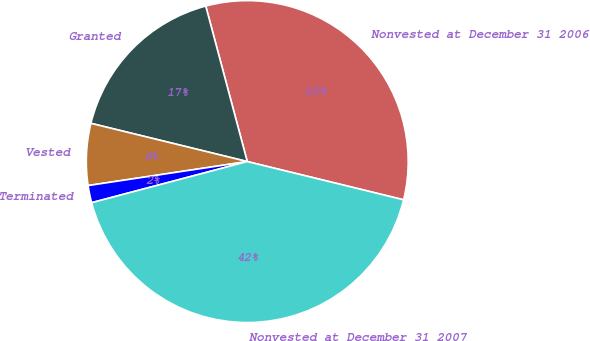Convert chart to OTSL. <chart><loc_0><loc_0><loc_500><loc_500><pie_chart><fcel>Nonvested at December 31 2006<fcel>Granted<fcel>Vested<fcel>Terminated<fcel>Nonvested at December 31 2007<nl><fcel>32.97%<fcel>17.03%<fcel>6.2%<fcel>1.73%<fcel>42.07%<nl></chart> 